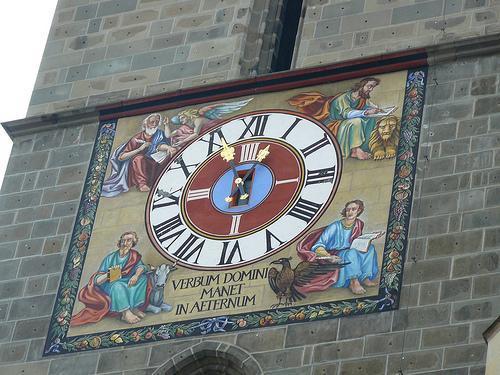How many hands does the clock have?
Give a very brief answer. 2. 